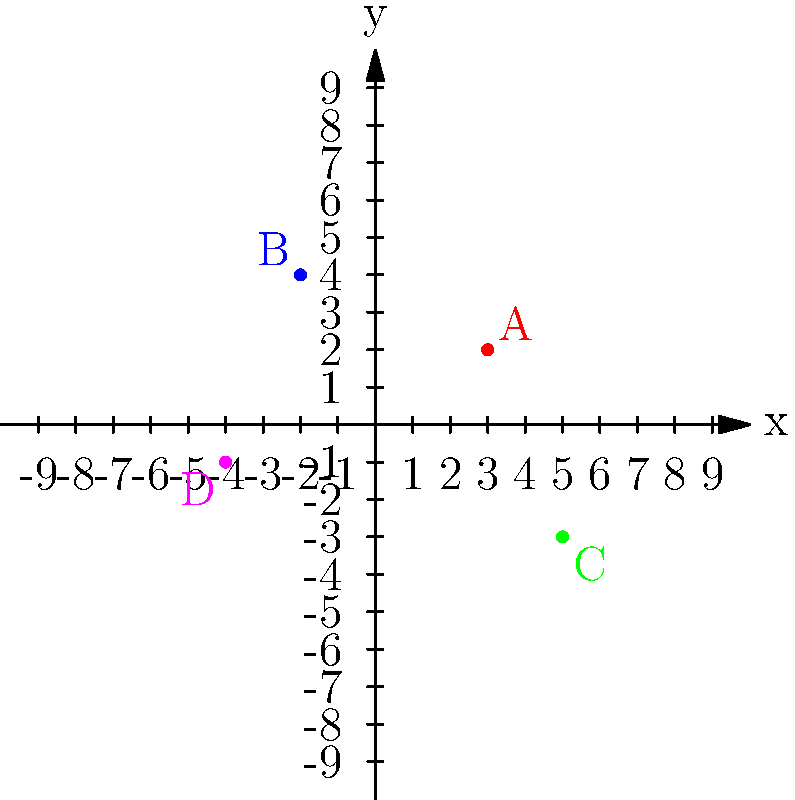Your daughter's Irish dance teacher wants to help the dancers visualize their positions on stage using a coordinate grid. The stage is represented by the grid above, where each point represents a dancer. If your daughter is at point A (3, 2), and she needs to move to point C (5, -3), how many units should she move along the x-axis and y-axis? Let's break this down step-by-step:

1. Your daughter's starting position (point A) is at (3, 2).
2. Her destination (point C) is at (5, -3).
3. To find the movement along the x-axis:
   - Subtract the x-coordinate of the starting point from the x-coordinate of the endpoint.
   - $5 - 3 = 2$
   - This means she needs to move 2 units to the right along the x-axis.
4. To find the movement along the y-axis:
   - Subtract the y-coordinate of the starting point from the y-coordinate of the endpoint.
   - $-3 - 2 = -5$
   - This means she needs to move 5 units down along the y-axis.

Therefore, your daughter should move 2 units to the right along the x-axis and 5 units down along the y-axis.
Answer: (2, -5) 